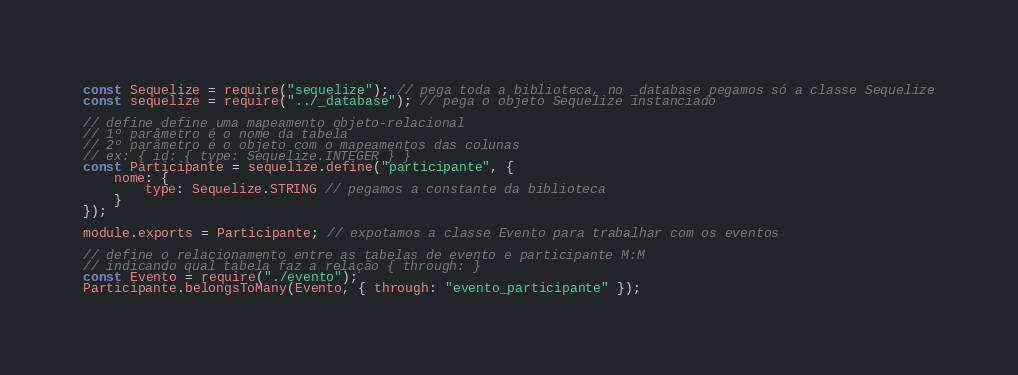<code> <loc_0><loc_0><loc_500><loc_500><_JavaScript_>const Sequelize = require("sequelize"); // pega toda a biblioteca, no _database pegamos só a classe Sequelize
const sequelize = require("../_database"); // pega o objeto Sequelize instanciado

// define define uma mapeamento objeto-relacional
// 1º parâmetro é o nome da tabela
// 2º parâmetro é o objeto com o mapeamentos das colunas
// ex: { id: { type: Sequelize.INTEGER } }
const Participante = sequelize.define("participante", {
    nome: {
        type: Sequelize.STRING // pegamos a constante da biblioteca
    }
});

module.exports = Participante; // expotamos a classe Evento para trabalhar com os eventos

// define o relacionamento entre as tabelas de evento e participante M:M
// indicando qual tabela faz a relação { through: }
const Evento = require("./evento");
Participante.belongsToMany(Evento, { through: "evento_participante" });</code> 